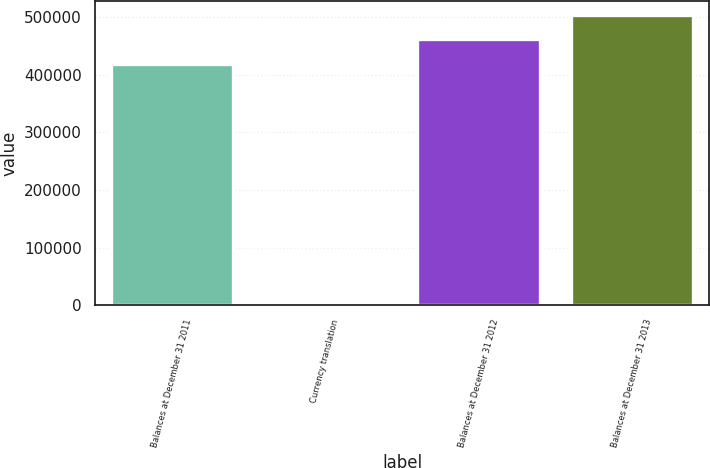Convert chart to OTSL. <chart><loc_0><loc_0><loc_500><loc_500><bar_chart><fcel>Balances at December 31 2011<fcel>Currency translation<fcel>Balances at December 31 2012<fcel>Balances at December 31 2013<nl><fcel>419053<fcel>2702<fcel>461333<fcel>503613<nl></chart> 